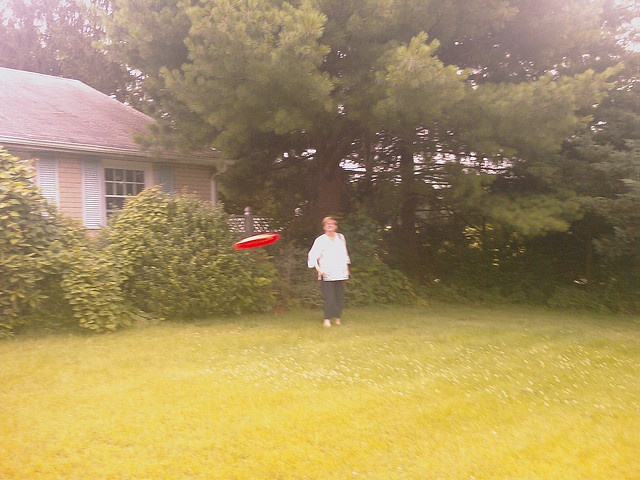Describe the objects in this image and their specific colors. I can see people in lavender, lightgray, gray, and lightpink tones and frisbee in lavender, red, brown, ivory, and salmon tones in this image. 